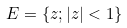Convert formula to latex. <formula><loc_0><loc_0><loc_500><loc_500>E = \{ z ; | z | < 1 \}</formula> 